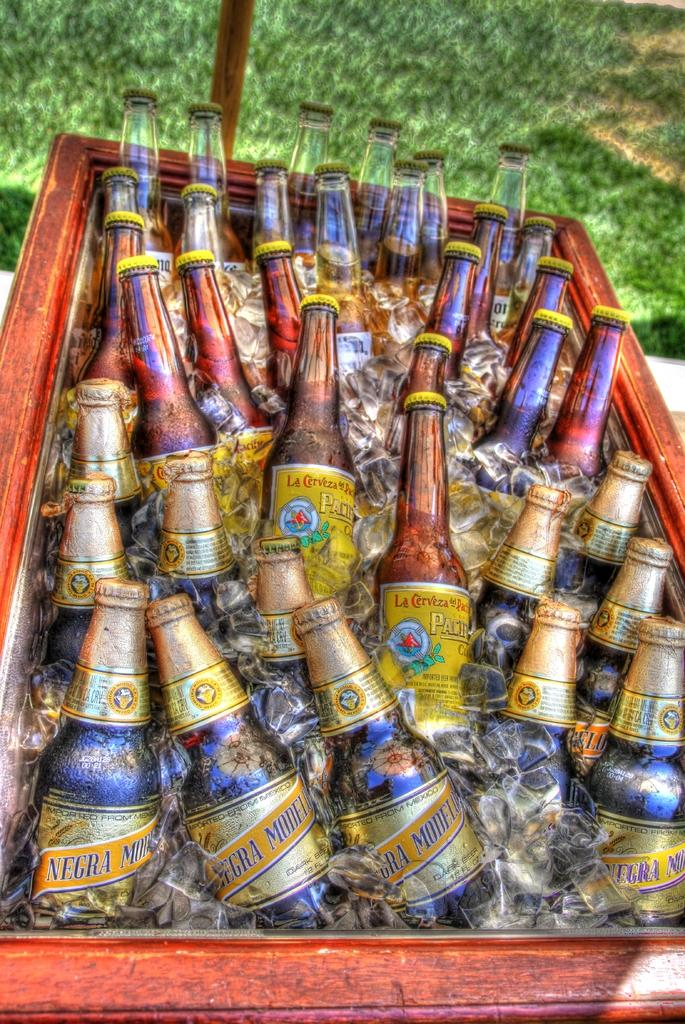<image>
Share a concise interpretation of the image provided. An ice chest full of different brands of Mexican beer. 